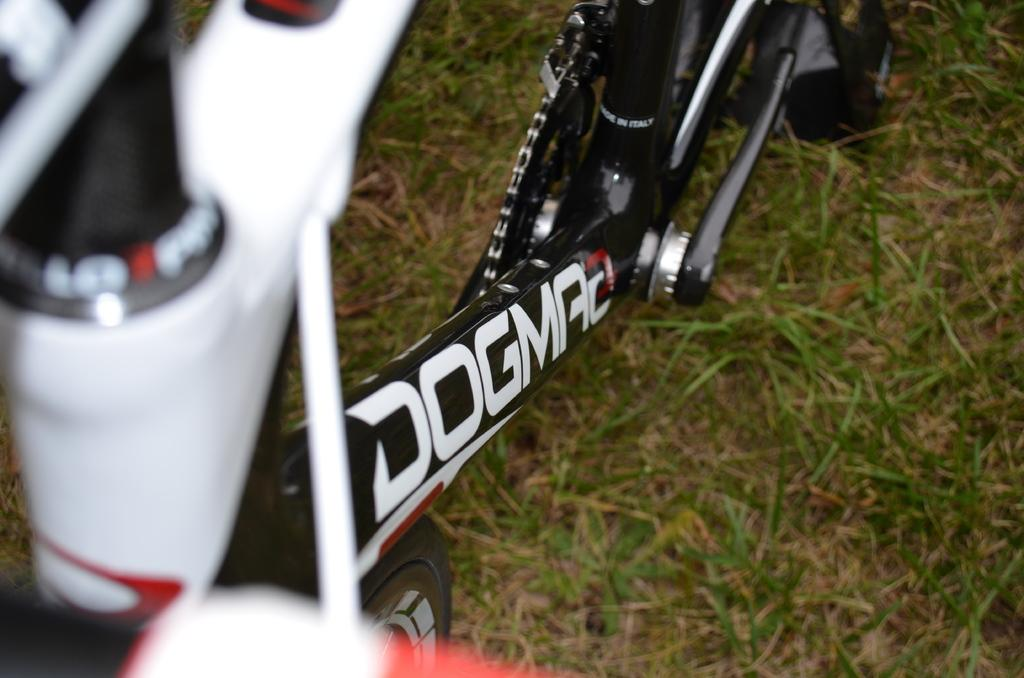What is the main object in the image? There is a bicycle in the image. Where is the bicycle located? The bicycle is on a grassland. Is there any text on the bicycle? Yes, there is text painted on the bicycle. What type of operation is being performed on the box in the image? There is no box present in the image, so no operation can be performed on it. 